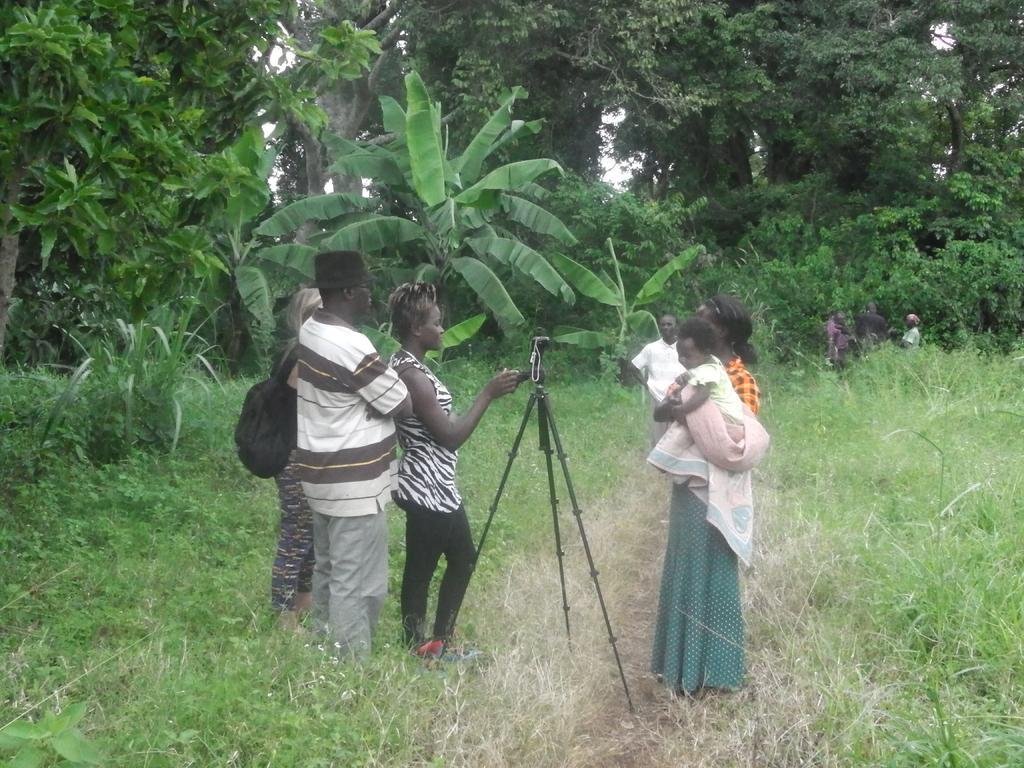How would you summarize this image in a sentence or two? Here we can see people. In-between of these people there is a camera stand. Here we can see grass. Background there are trees. 